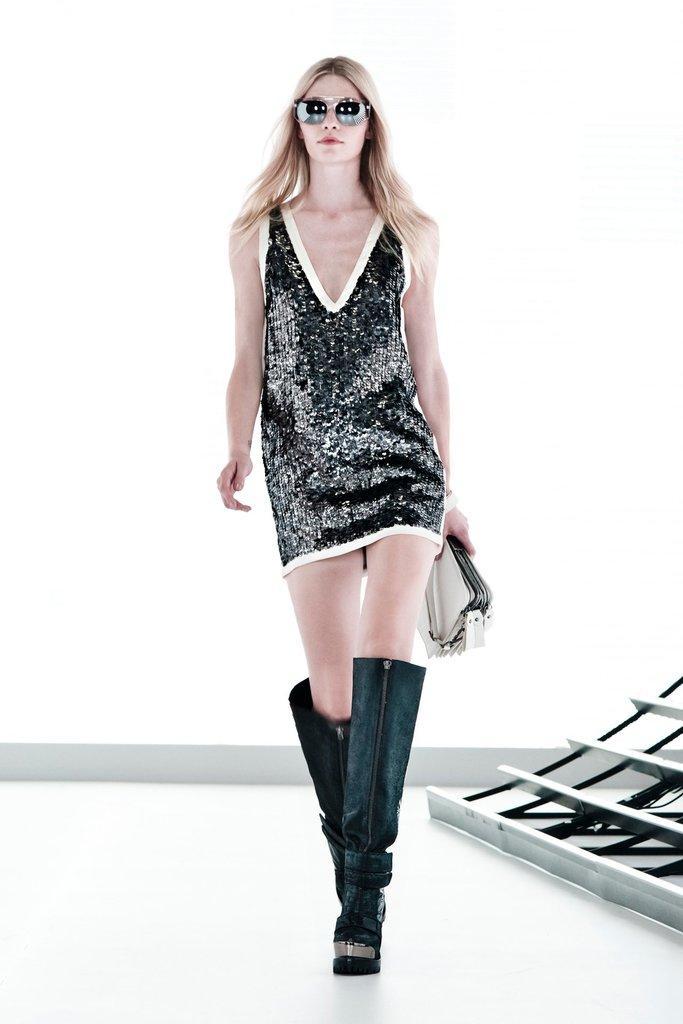Please provide a concise description of this image. In this image I can see the person with white and black color dress and also goggles. The person is holding the wallet. In the back I can see the white color wall. 